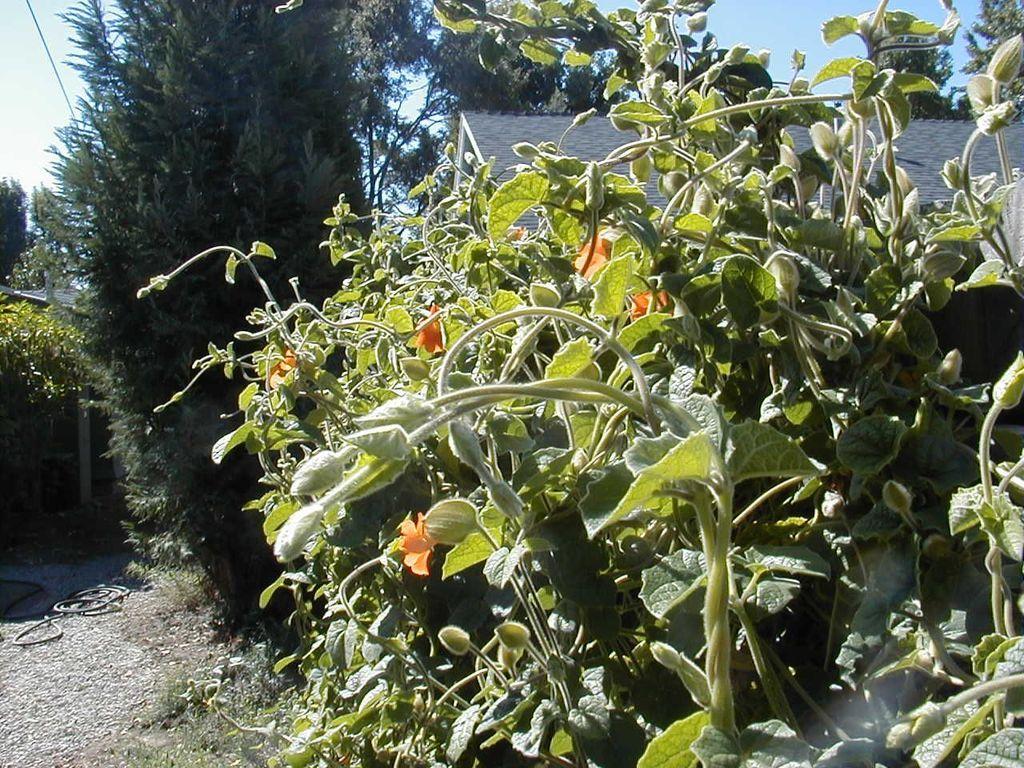How would you summarize this image in a sentence or two? In this image there are plants and a house, in the background there are trees and the sky, in the bottom left there is land. 